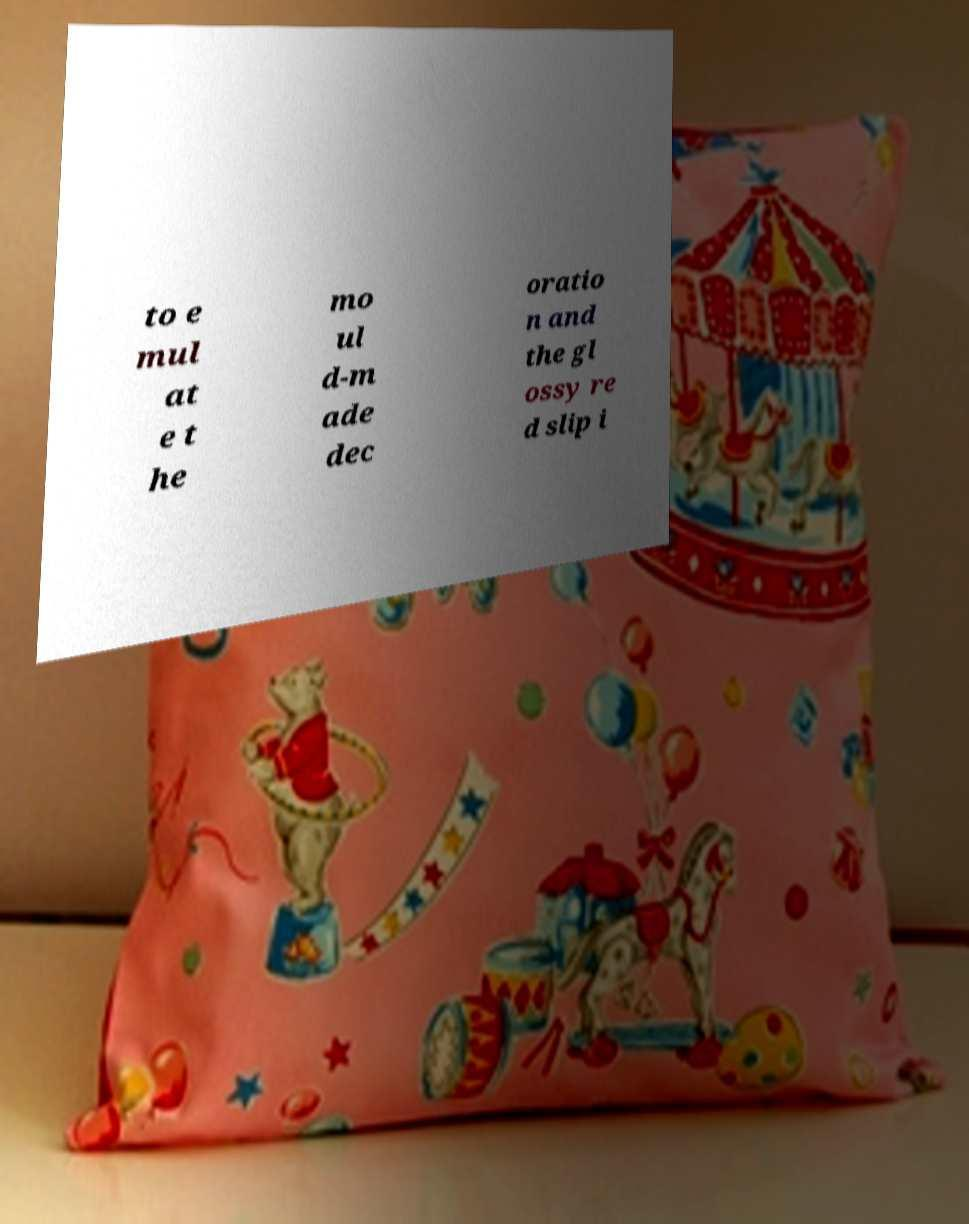Can you accurately transcribe the text from the provided image for me? to e mul at e t he mo ul d-m ade dec oratio n and the gl ossy re d slip i 